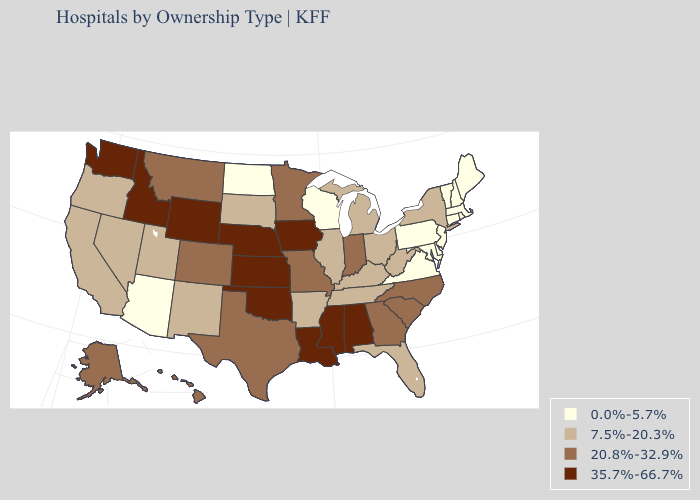Does Illinois have the lowest value in the MidWest?
Concise answer only. No. Does Missouri have the same value as Indiana?
Short answer required. Yes. Name the states that have a value in the range 7.5%-20.3%?
Concise answer only. Arkansas, California, Florida, Illinois, Kentucky, Michigan, Nevada, New Mexico, New York, Ohio, Oregon, South Dakota, Tennessee, Utah, West Virginia. Which states hav the highest value in the Northeast?
Keep it brief. New York. What is the highest value in states that border Connecticut?
Be succinct. 7.5%-20.3%. Name the states that have a value in the range 35.7%-66.7%?
Keep it brief. Alabama, Idaho, Iowa, Kansas, Louisiana, Mississippi, Nebraska, Oklahoma, Washington, Wyoming. Which states hav the highest value in the MidWest?
Quick response, please. Iowa, Kansas, Nebraska. What is the value of North Carolina?
Concise answer only. 20.8%-32.9%. What is the value of Massachusetts?
Quick response, please. 0.0%-5.7%. Among the states that border Arizona , does Colorado have the highest value?
Keep it brief. Yes. Name the states that have a value in the range 20.8%-32.9%?
Concise answer only. Alaska, Colorado, Georgia, Hawaii, Indiana, Minnesota, Missouri, Montana, North Carolina, South Carolina, Texas. Among the states that border Oklahoma , does Missouri have the lowest value?
Give a very brief answer. No. Which states have the highest value in the USA?
Write a very short answer. Alabama, Idaho, Iowa, Kansas, Louisiana, Mississippi, Nebraska, Oklahoma, Washington, Wyoming. Name the states that have a value in the range 20.8%-32.9%?
Short answer required. Alaska, Colorado, Georgia, Hawaii, Indiana, Minnesota, Missouri, Montana, North Carolina, South Carolina, Texas. Does Wisconsin have the same value as Arizona?
Be succinct. Yes. 